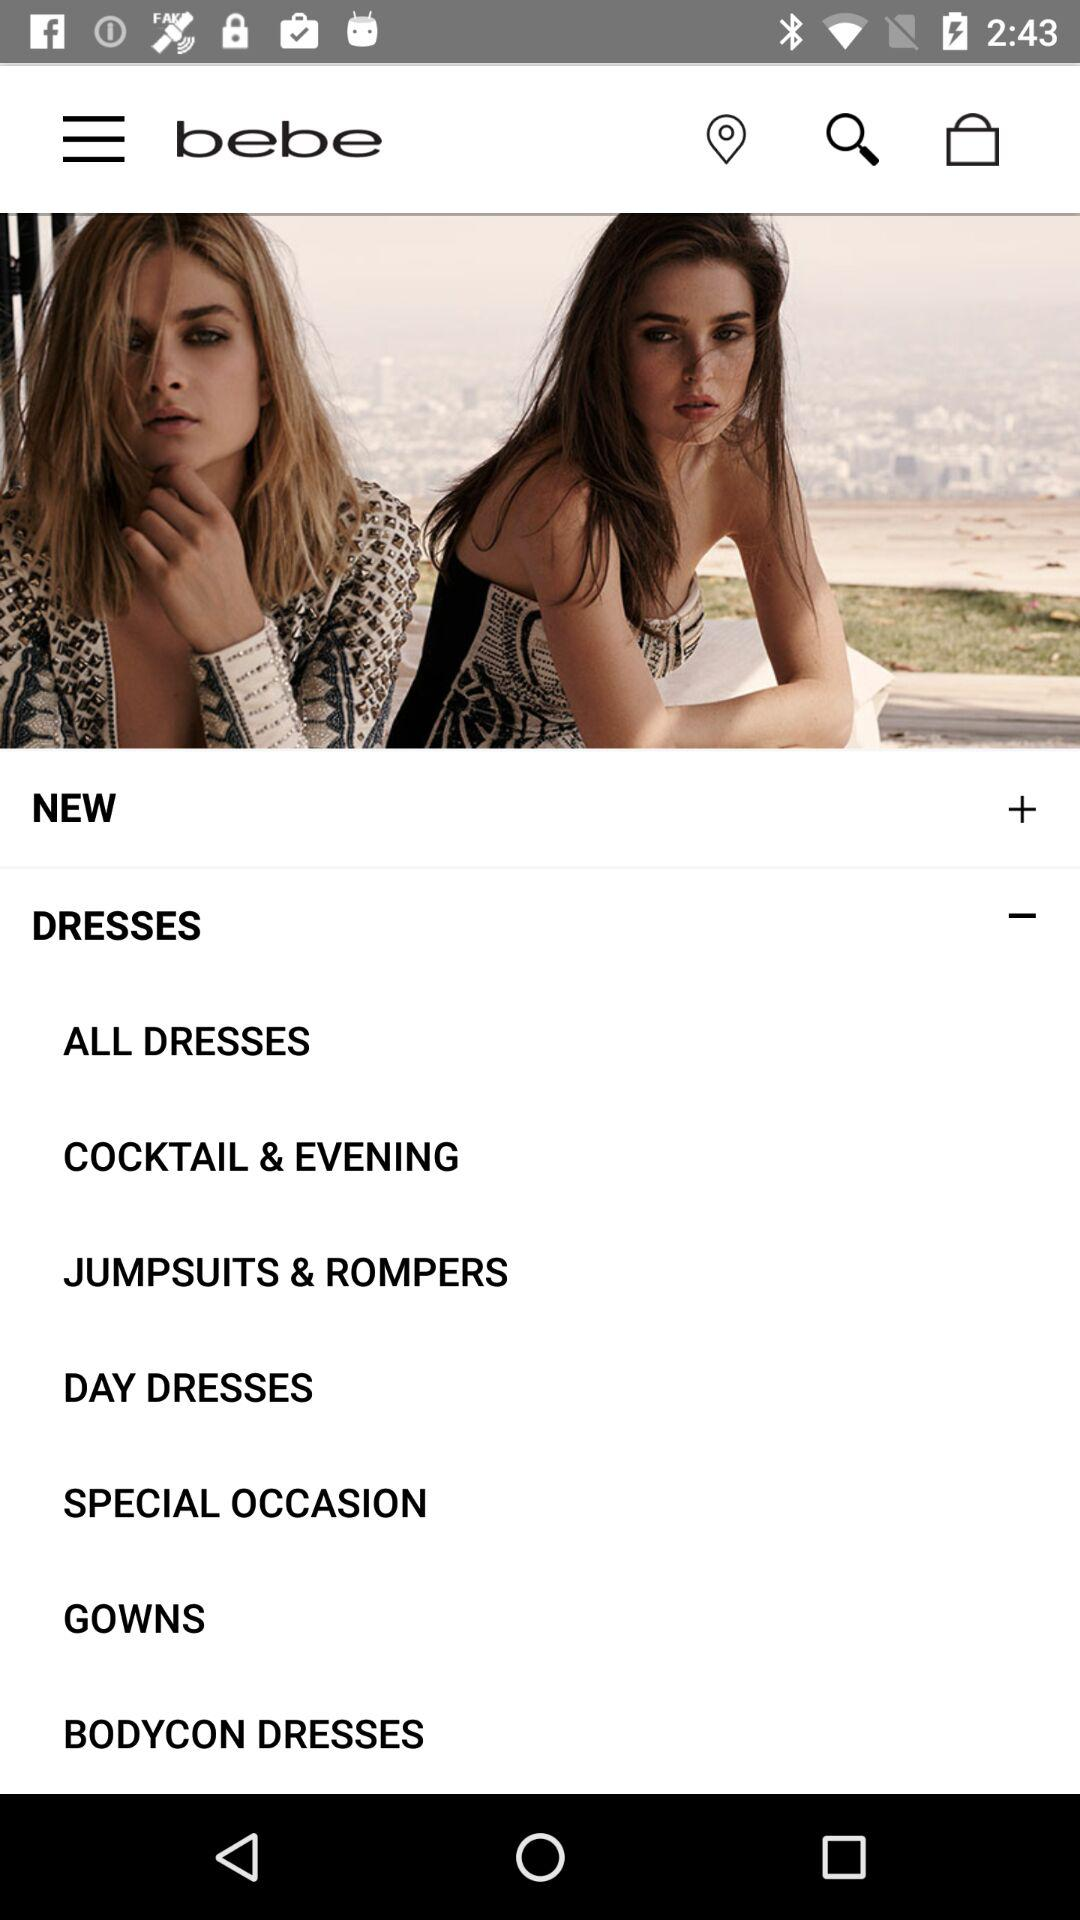What is the application name? The application name is "bebe". 